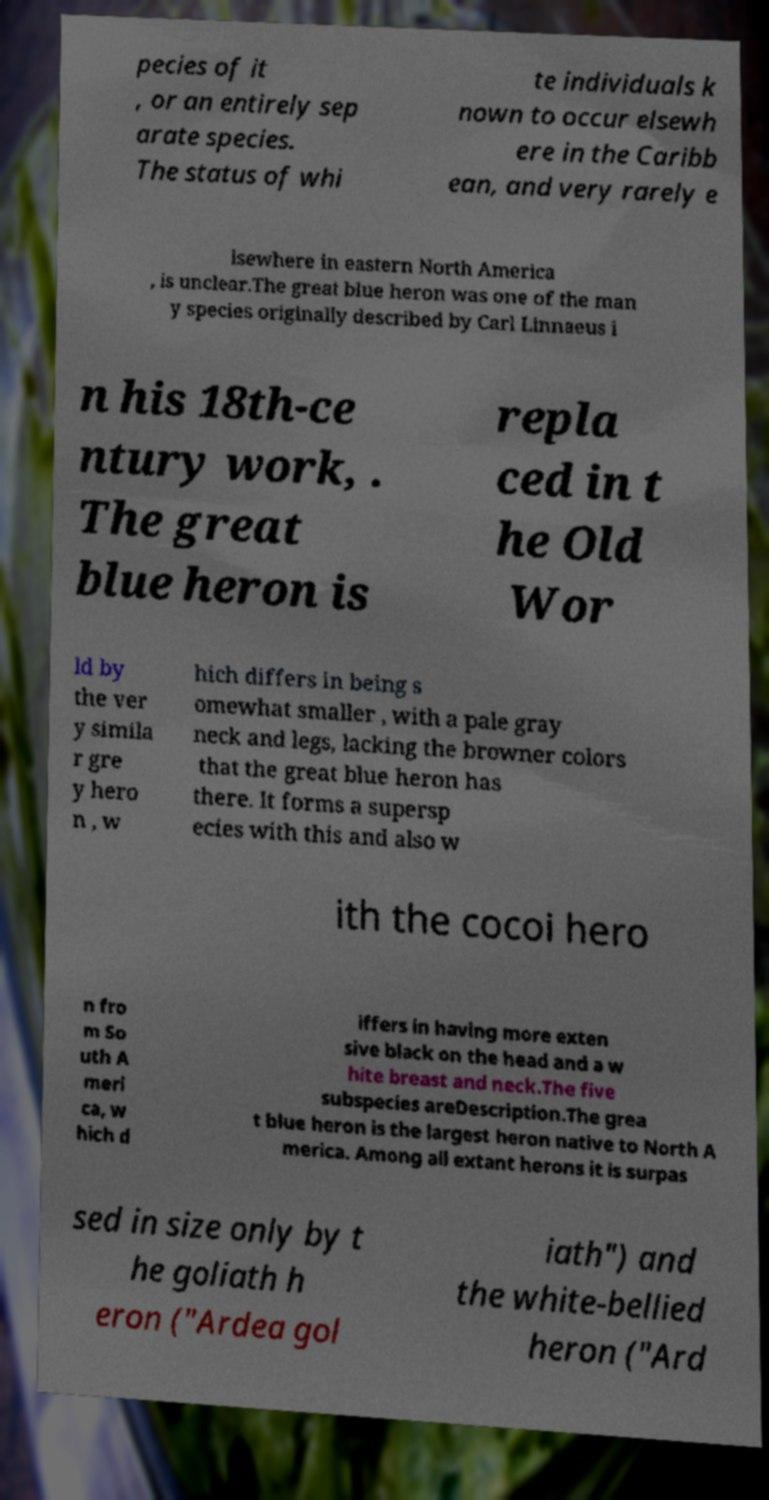Could you assist in decoding the text presented in this image and type it out clearly? pecies of it , or an entirely sep arate species. The status of whi te individuals k nown to occur elsewh ere in the Caribb ean, and very rarely e lsewhere in eastern North America , is unclear.The great blue heron was one of the man y species originally described by Carl Linnaeus i n his 18th-ce ntury work, . The great blue heron is repla ced in t he Old Wor ld by the ver y simila r gre y hero n , w hich differs in being s omewhat smaller , with a pale gray neck and legs, lacking the browner colors that the great blue heron has there. It forms a supersp ecies with this and also w ith the cocoi hero n fro m So uth A meri ca, w hich d iffers in having more exten sive black on the head and a w hite breast and neck.The five subspecies areDescription.The grea t blue heron is the largest heron native to North A merica. Among all extant herons it is surpas sed in size only by t he goliath h eron ("Ardea gol iath") and the white-bellied heron ("Ard 